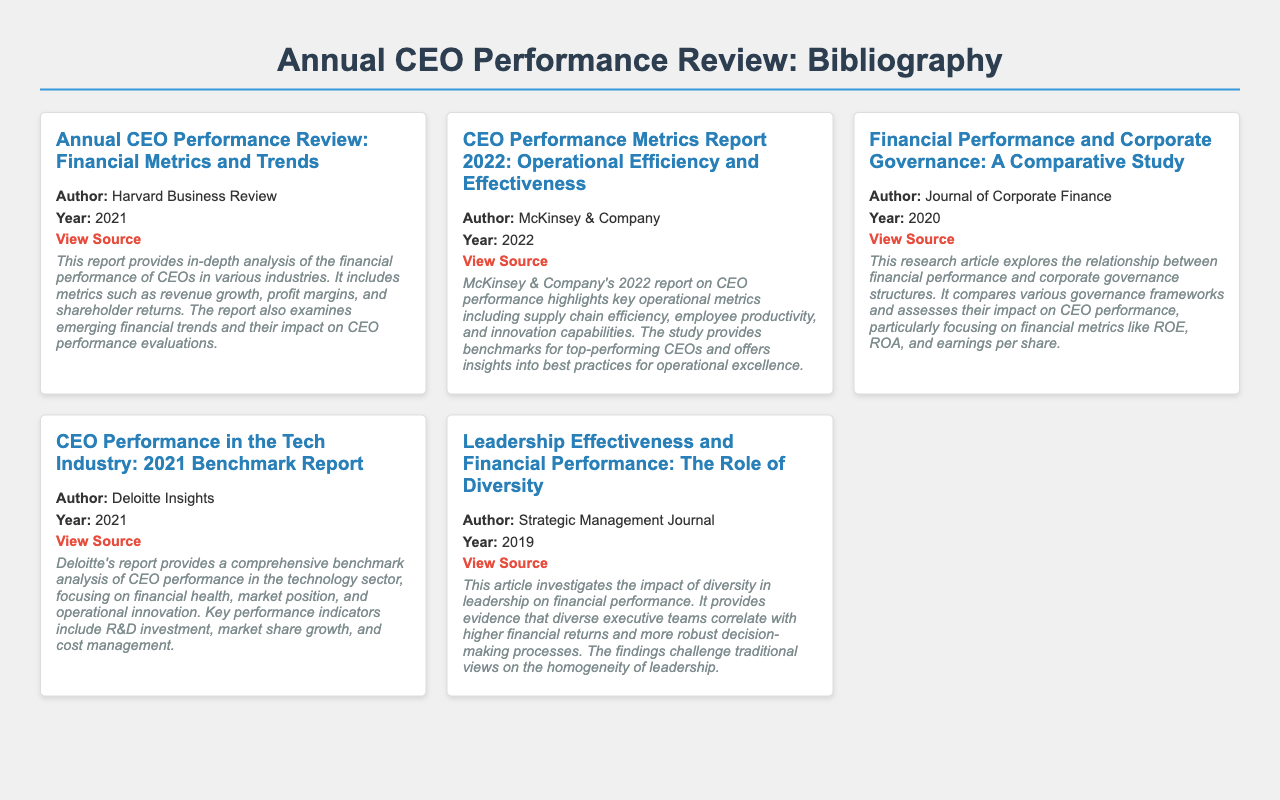What is the title of the report authored by Harvard Business Review? The title can be found in the entry of the report, and it is "Annual CEO Performance Review: Financial Metrics and Trends".
Answer: Annual CEO Performance Review: Financial Metrics and Trends Who authored the report on operational efficiency for 2022? The author's name is mentioned in the entry, which states that it is McKinsey & Company.
Answer: McKinsey & Company What year was the report "Leadership Effectiveness and Financial Performance: The Role of Diversity" published? The publication year is indicated in the entry for that report, which is 2019.
Answer: 2019 In which journal was the report on financial performance and corporate governance published? The report is associated with the Journal of Corporate Finance, as listed in the entry.
Answer: Journal of Corporate Finance How many key performance indicators does the Deloitte report mention for the tech industry? The Deloitte report details various metrics and includes key performance indicators, but the exact number is not stated in the summary.
Answer: Not specified What is a financial metric mentioned in the report authored by Harvard Business Review? The report discusses several metrics, including revenue growth, which is explicitly mentioned as a part of the analysis.
Answer: Revenue growth Which company released a benchmark report specifically for CEO performance in the tech industry? The entry clearly states that the report was released by Deloitte Insights.
Answer: Deloitte Insights What does the report from Strategic Management Journal highlight about diverse executive teams? The report provides evidence that diverse executive teams correlate with higher financial returns; this is stated in the abstract.
Answer: Higher financial returns 